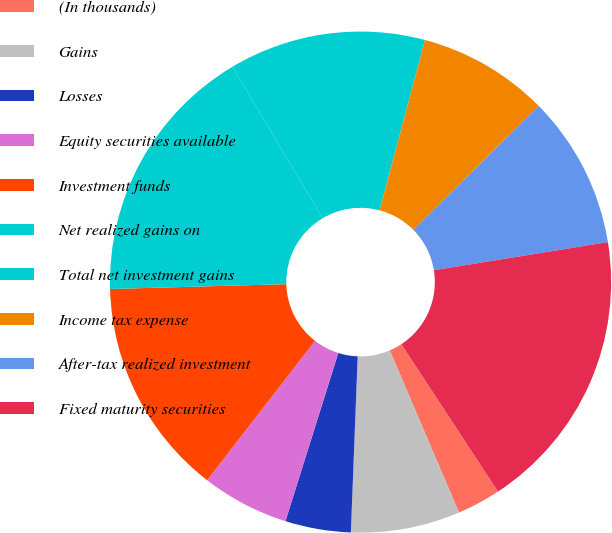<chart> <loc_0><loc_0><loc_500><loc_500><pie_chart><fcel>(In thousands)<fcel>Gains<fcel>Losses<fcel>Equity securities available<fcel>Investment funds<fcel>Net realized gains on<fcel>Total net investment gains<fcel>Income tax expense<fcel>After-tax realized investment<fcel>Fixed maturity securities<nl><fcel>2.82%<fcel>7.04%<fcel>4.23%<fcel>5.64%<fcel>14.08%<fcel>16.9%<fcel>12.68%<fcel>8.45%<fcel>9.86%<fcel>18.31%<nl></chart> 